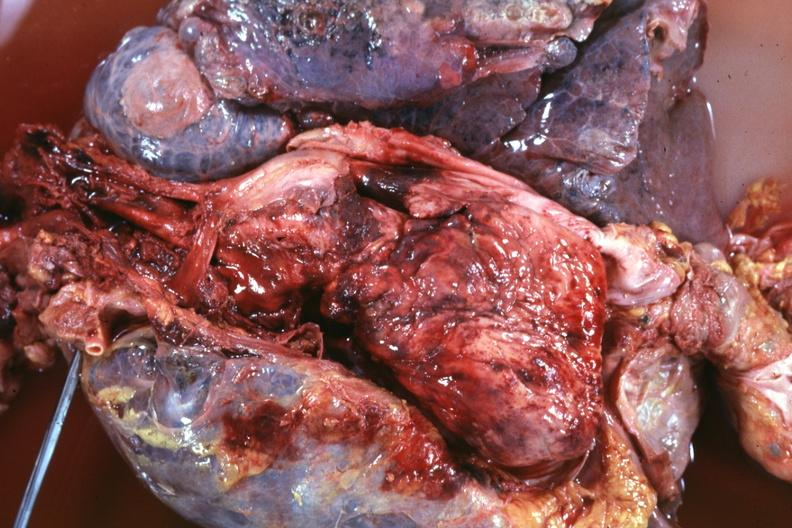what is present?
Answer the question using a single word or phrase. Malignant thymoma 